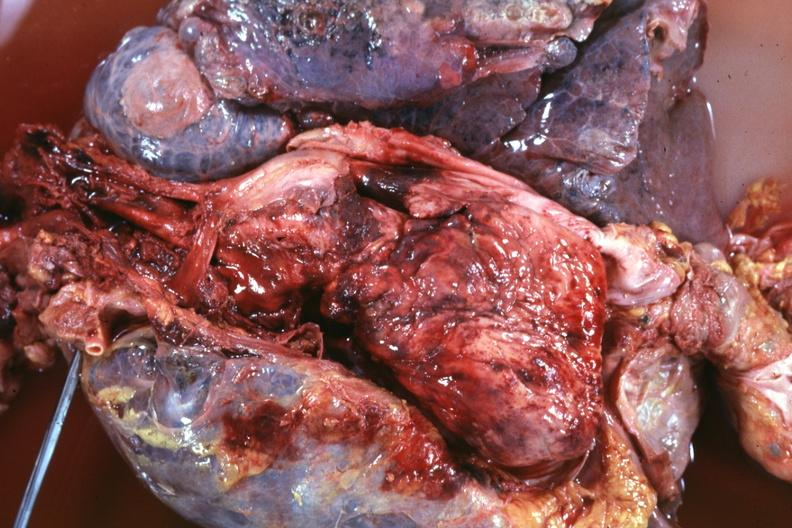what is present?
Answer the question using a single word or phrase. Malignant thymoma 